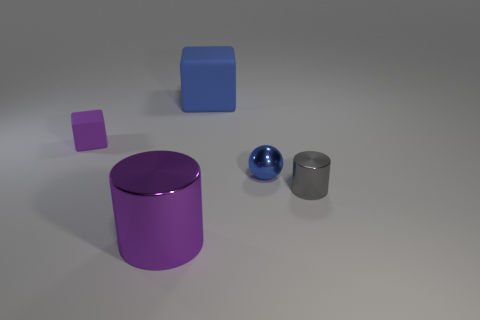Does the ball that is left of the small gray cylinder have the same size as the cube that is to the right of the small purple rubber object?
Your answer should be compact. No. How many objects are both to the right of the large cylinder and behind the blue shiny thing?
Ensure brevity in your answer.  1. What color is the tiny object that is the same shape as the big blue object?
Keep it short and to the point. Purple. Are there fewer large cyan balls than matte cubes?
Provide a short and direct response. Yes. There is a sphere; is its size the same as the rubber block that is on the right side of the large purple metallic object?
Offer a terse response. No. The big object in front of the block that is on the right side of the small purple matte object is what color?
Your answer should be compact. Purple. How many objects are either purple objects in front of the gray shiny cylinder or large objects that are in front of the small gray shiny cylinder?
Give a very brief answer. 1. Is the size of the blue matte block the same as the purple metal object?
Your answer should be very brief. Yes. Are there any other things that are the same size as the blue rubber object?
Give a very brief answer. Yes. Is the shape of the purple thing that is on the right side of the small matte cube the same as the blue thing that is in front of the blue rubber block?
Offer a very short reply. No. 